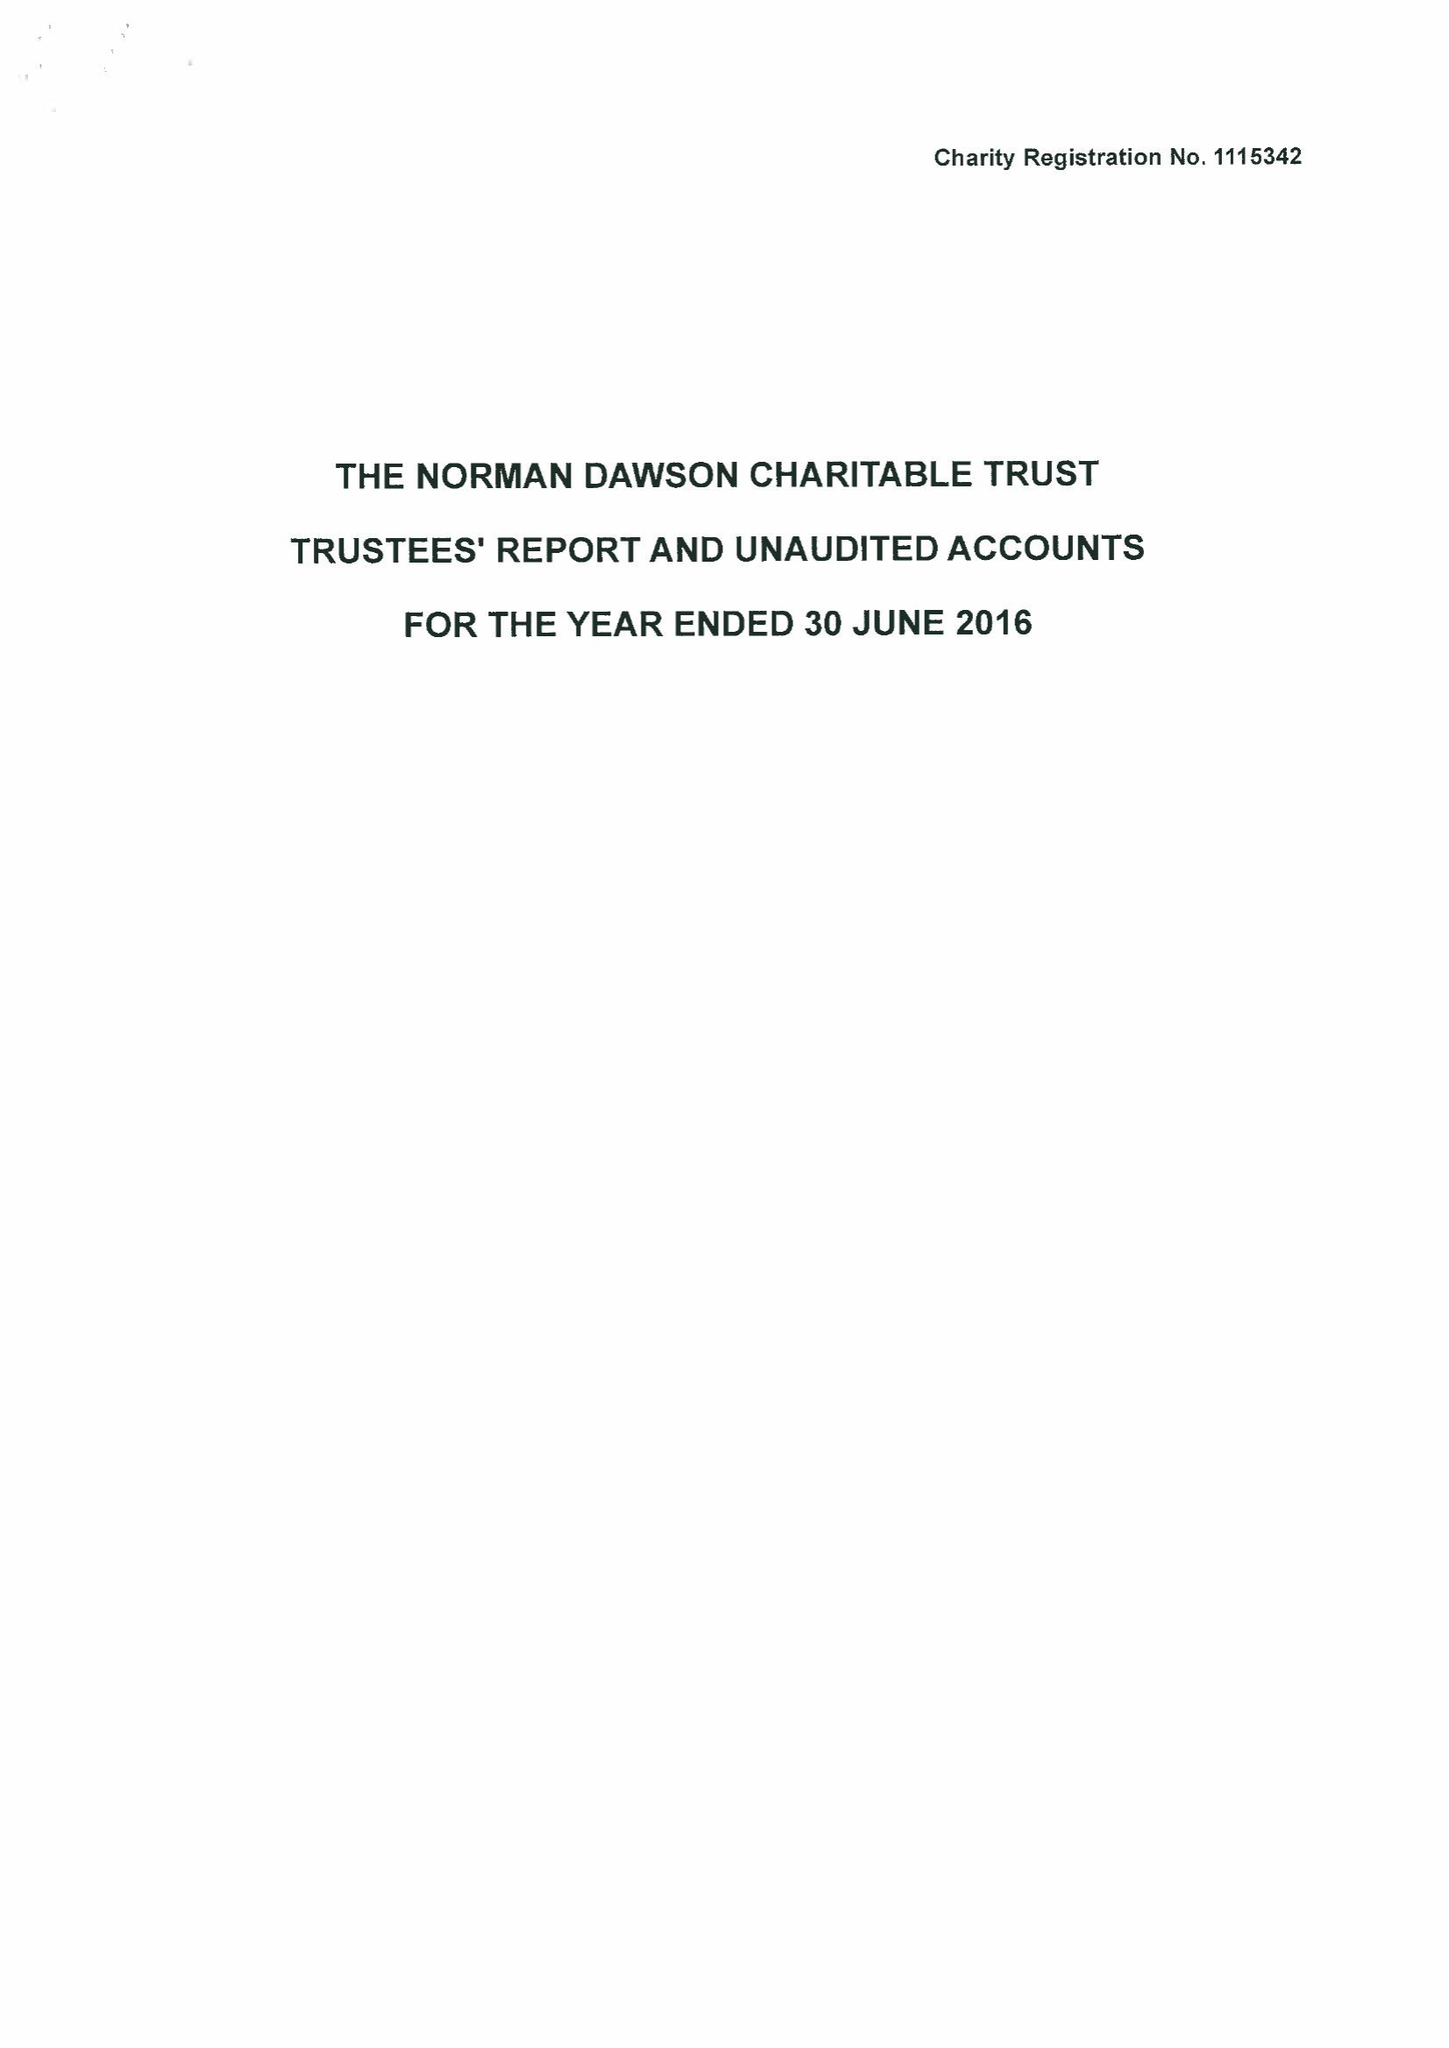What is the value for the address__post_town?
Answer the question using a single word or phrase. KIDDERMINSTER 